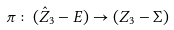Convert formula to latex. <formula><loc_0><loc_0><loc_500><loc_500>\pi \colon ( \hat { Z } _ { 3 } - E ) \rightarrow ( Z _ { 3 } - \Sigma )</formula> 